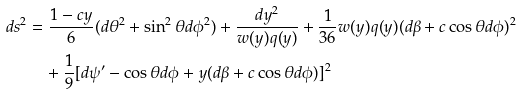Convert formula to latex. <formula><loc_0><loc_0><loc_500><loc_500>d s ^ { 2 } & = \frac { 1 - c y } { 6 } ( d \theta ^ { 2 } + \sin ^ { 2 } \theta d \phi ^ { 2 } ) + \frac { d y ^ { 2 } } { w ( y ) q ( y ) } + \frac { 1 } { 3 6 } w ( y ) q ( y ) ( d \beta + c \cos \theta d \phi ) ^ { 2 } \\ & \quad + \frac { 1 } { 9 } [ d \psi ^ { \prime } - \cos \theta d \phi + y ( d \beta + c \cos \theta d \phi ) ] ^ { 2 }</formula> 